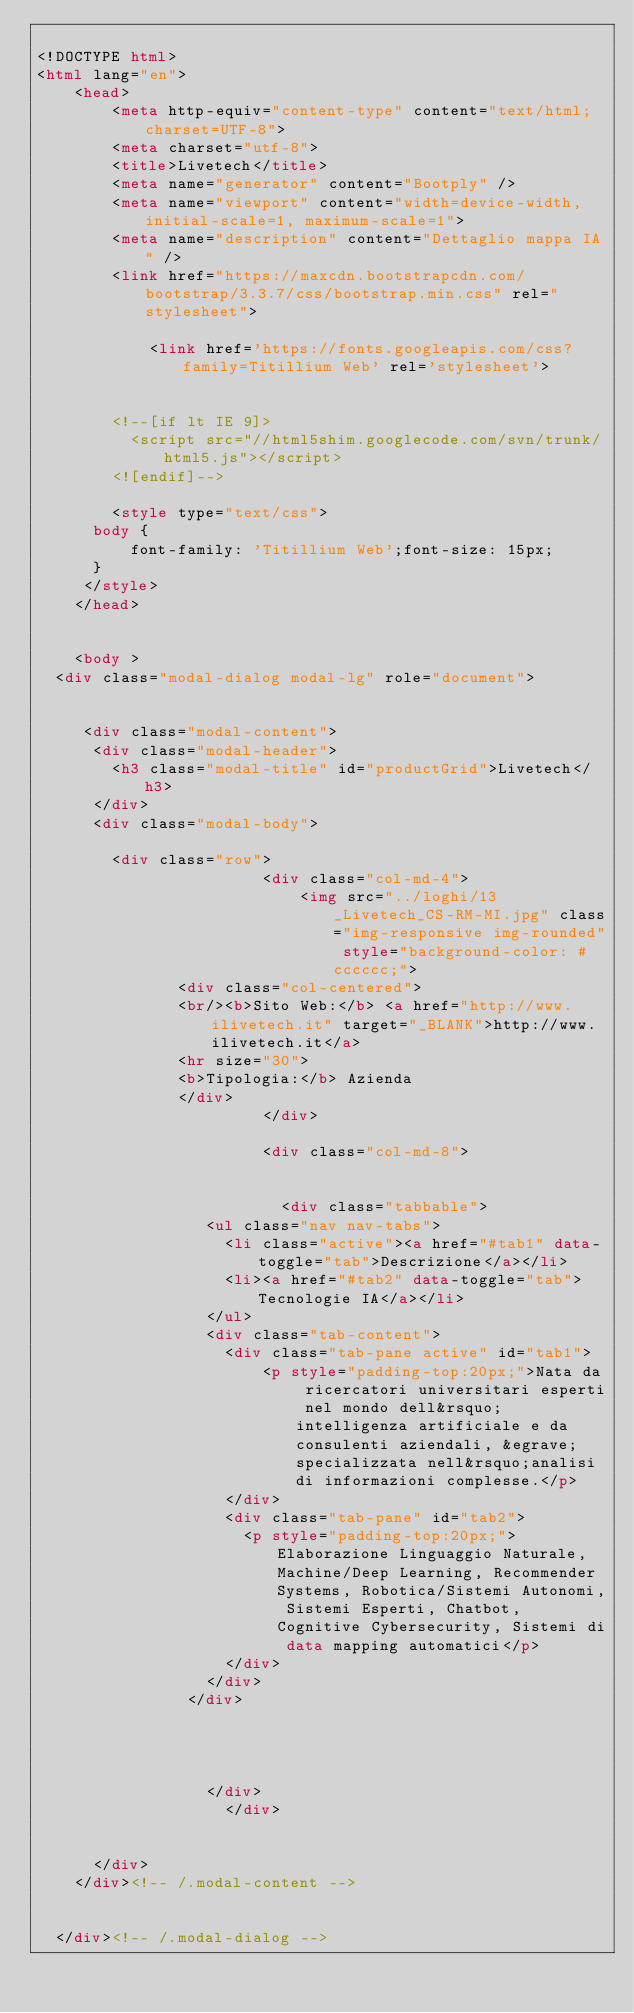Convert code to text. <code><loc_0><loc_0><loc_500><loc_500><_HTML_>
<!DOCTYPE html>
<html lang="en">
    <head>
        <meta http-equiv="content-type" content="text/html; charset=UTF-8"> 
        <meta charset="utf-8">
        <title>Livetech</title>
        <meta name="generator" content="Bootply" />
        <meta name="viewport" content="width=device-width, initial-scale=1, maximum-scale=1">
        <meta name="description" content="Dettaglio mappa IA" />
        <link href="https://maxcdn.bootstrapcdn.com/bootstrap/3.3.7/css/bootstrap.min.css" rel="stylesheet">
        
        		<link href='https://fonts.googleapis.com/css?family=Titillium Web' rel='stylesheet'>
        
        
        <!--[if lt IE 9]>
          <script src="//html5shim.googlecode.com/svn/trunk/html5.js"></script>
        <![endif]-->        
        
        <style type="text/css">		
			body {
			    font-family: 'Titillium Web';font-size: 15px;
			}
		 </style>
    </head>
    
    
    <body >
  <div class="modal-dialog modal-lg" role="document">

  
     <div class="modal-content">
      <div class="modal-header">
        <h3 class="modal-title" id="productGrid">Livetech</h3>
      </div>
      <div class="modal-body">

        <div class="row">
                        <div class="col-md-4">
                            <img src="../loghi/13_Livetech_CS-RM-MI.jpg" class="img-responsive img-rounded" style="background-color: #cccccc;">
							 <div class="col-centered">
							 <br/><b>Sito Web:</b> <a href="http://www.ilivetech.it" target="_BLANK">http://www.ilivetech.it</a>
							 <hr size="30">
							 <b>Tipologia:</b> Azienda						 
							 </div>
                        </div>
						
                        <div class="col-md-8">
          
                          
                          <div class="tabbable"> 
        					<ul class="nav nav-tabs">
        						<li class="active"><a href="#tab1" data-toggle="tab">Descrizione</a></li>
        						<li><a href="#tab2" data-toggle="tab">Tecnologie IA</a></li>
        					</ul>
        					<div class="tab-content">
        						<div class="tab-pane active" id="tab1">
            						<p style="padding-top:20px;">Nata da ricercatori universitari esperti nel mondo dell&rsquo;intelligenza artificiale e da consulenti aziendali, &egrave; specializzata nell&rsquo;analisi di informazioni complesse.</p>
        						</div>
        						<div class="tab-pane" id="tab2">
        							<p style="padding-top:20px;">Elaborazione Linguaggio Naturale, Machine/Deep Learning, Recommender Systems, Robotica/Sistemi Autonomi, Sistemi Esperti, Chatbot, Cognitive Cybersecurity, Sistemi di data mapping automatici</p>
        						</div>
        					</div>
        				</div>
                          
                          
                          
          
          				</div>
                    </div>
        
       
      </div>
    </div><!-- /.modal-content --> 
  

  </div><!-- /.modal-dialog -->
        </code> 